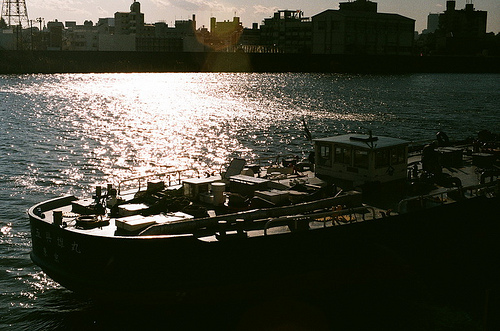Are there both boats and ropes in the picture? The image prominently displays a boat but lacks any visible ropes. 